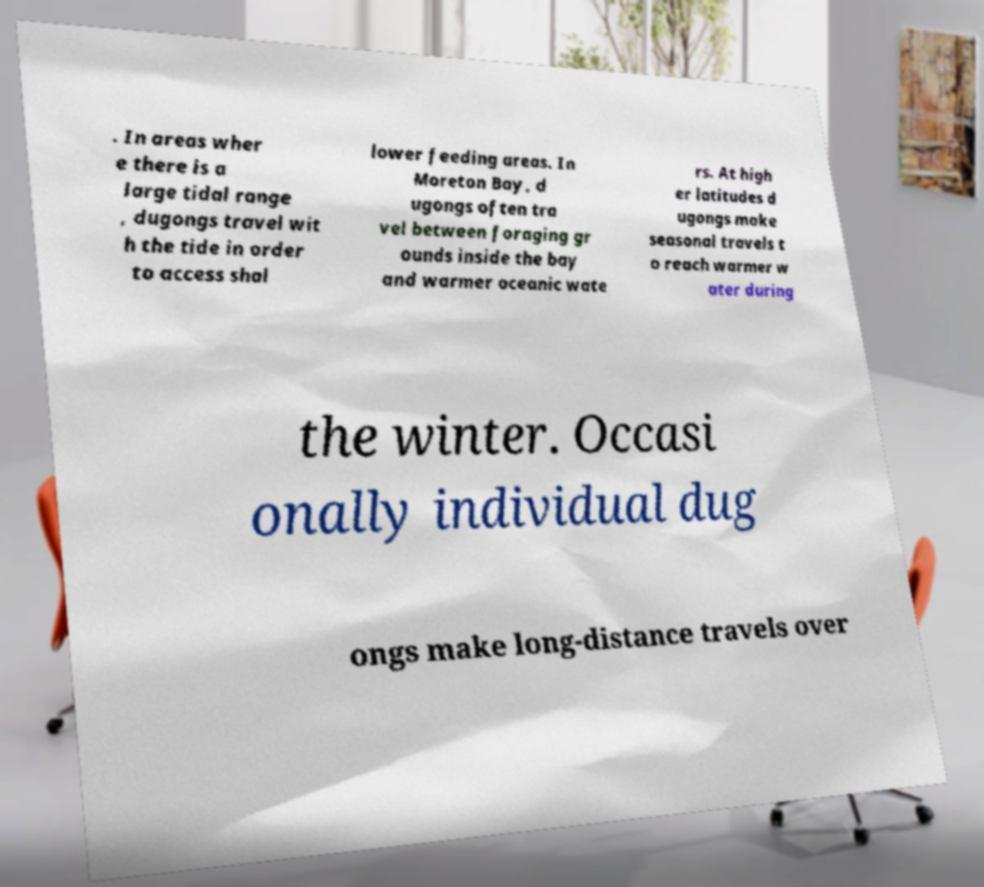What messages or text are displayed in this image? I need them in a readable, typed format. . In areas wher e there is a large tidal range , dugongs travel wit h the tide in order to access shal lower feeding areas. In Moreton Bay, d ugongs often tra vel between foraging gr ounds inside the bay and warmer oceanic wate rs. At high er latitudes d ugongs make seasonal travels t o reach warmer w ater during the winter. Occasi onally individual dug ongs make long-distance travels over 